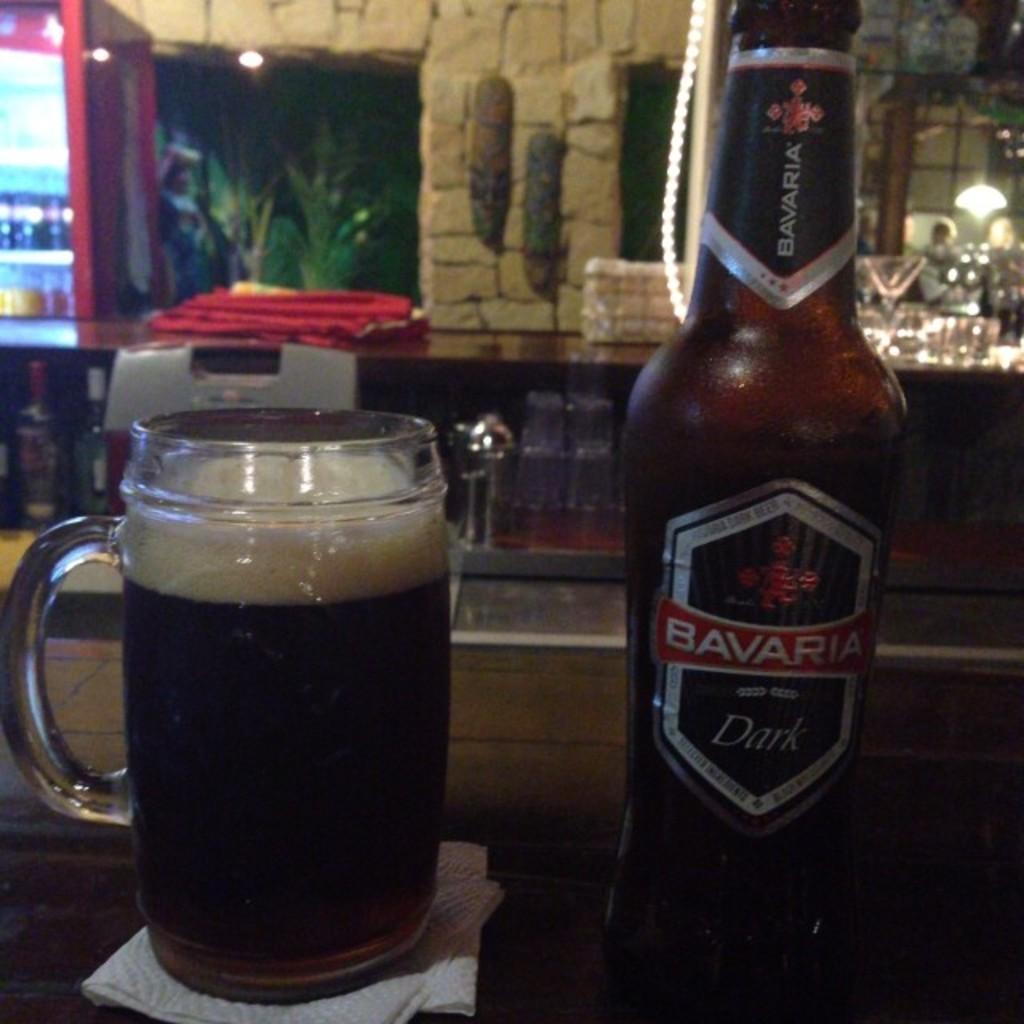This is drinks?
Make the answer very short. Yes. 